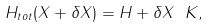<formula> <loc_0><loc_0><loc_500><loc_500>H _ { t o t } ( X + \delta X ) = H + \delta X \ K ,</formula> 